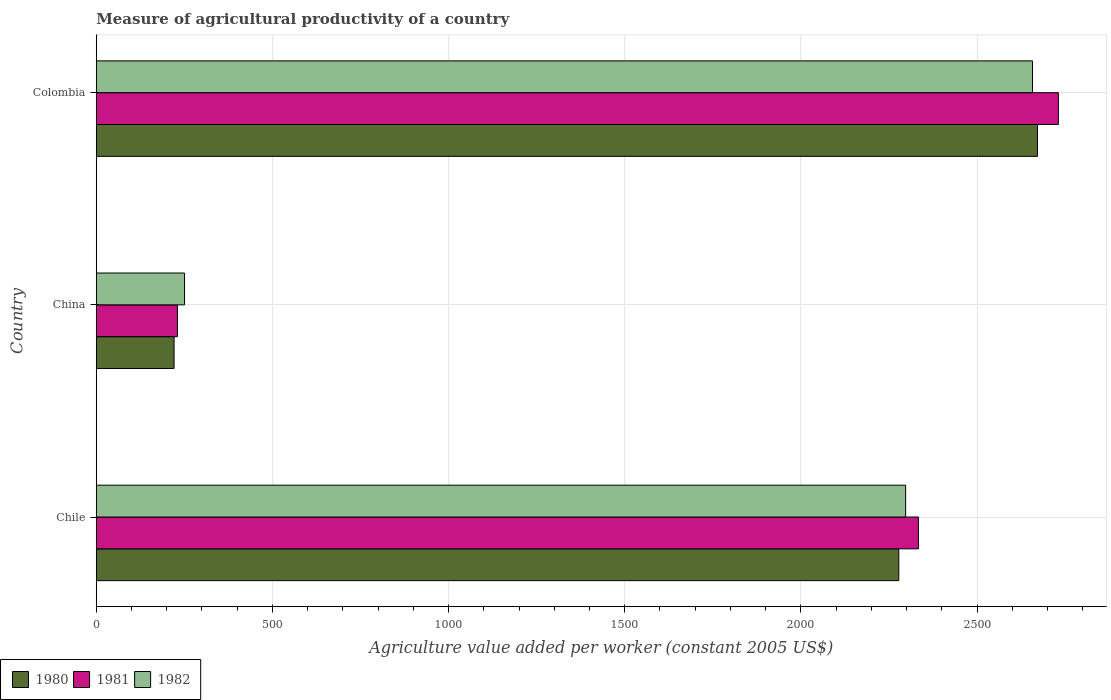How many different coloured bars are there?
Your answer should be very brief. 3. In how many cases, is the number of bars for a given country not equal to the number of legend labels?
Provide a succinct answer. 0. What is the measure of agricultural productivity in 1980 in Colombia?
Your answer should be compact. 2671.6. Across all countries, what is the maximum measure of agricultural productivity in 1981?
Keep it short and to the point. 2731.02. Across all countries, what is the minimum measure of agricultural productivity in 1980?
Offer a terse response. 220.85. In which country was the measure of agricultural productivity in 1982 minimum?
Your answer should be compact. China. What is the total measure of agricultural productivity in 1981 in the graph?
Offer a terse response. 5295.08. What is the difference between the measure of agricultural productivity in 1981 in Chile and that in China?
Provide a short and direct response. 2103.3. What is the difference between the measure of agricultural productivity in 1981 in China and the measure of agricultural productivity in 1982 in Chile?
Your answer should be very brief. -2067.07. What is the average measure of agricultural productivity in 1982 per country?
Ensure brevity in your answer.  1735.19. What is the difference between the measure of agricultural productivity in 1982 and measure of agricultural productivity in 1981 in Colombia?
Offer a terse response. -73.46. In how many countries, is the measure of agricultural productivity in 1980 greater than 2000 US$?
Ensure brevity in your answer.  2. What is the ratio of the measure of agricultural productivity in 1982 in China to that in Colombia?
Ensure brevity in your answer.  0.09. Is the measure of agricultural productivity in 1981 in Chile less than that in China?
Your response must be concise. No. Is the difference between the measure of agricultural productivity in 1982 in Chile and China greater than the difference between the measure of agricultural productivity in 1981 in Chile and China?
Your answer should be compact. No. What is the difference between the highest and the second highest measure of agricultural productivity in 1981?
Offer a terse response. 397.34. What is the difference between the highest and the lowest measure of agricultural productivity in 1980?
Offer a terse response. 2450.74. What is the difference between two consecutive major ticks on the X-axis?
Provide a succinct answer. 500. Are the values on the major ticks of X-axis written in scientific E-notation?
Provide a short and direct response. No. Does the graph contain any zero values?
Offer a very short reply. No. Does the graph contain grids?
Make the answer very short. Yes. How many legend labels are there?
Ensure brevity in your answer.  3. How are the legend labels stacked?
Provide a short and direct response. Horizontal. What is the title of the graph?
Offer a terse response. Measure of agricultural productivity of a country. Does "1977" appear as one of the legend labels in the graph?
Offer a very short reply. No. What is the label or title of the X-axis?
Your answer should be very brief. Agriculture value added per worker (constant 2005 US$). What is the Agriculture value added per worker (constant 2005 US$) in 1980 in Chile?
Your answer should be very brief. 2277.98. What is the Agriculture value added per worker (constant 2005 US$) in 1981 in Chile?
Offer a very short reply. 2333.68. What is the Agriculture value added per worker (constant 2005 US$) in 1982 in Chile?
Your answer should be compact. 2297.45. What is the Agriculture value added per worker (constant 2005 US$) of 1980 in China?
Make the answer very short. 220.85. What is the Agriculture value added per worker (constant 2005 US$) in 1981 in China?
Your answer should be compact. 230.38. What is the Agriculture value added per worker (constant 2005 US$) of 1982 in China?
Your answer should be compact. 250.55. What is the Agriculture value added per worker (constant 2005 US$) of 1980 in Colombia?
Give a very brief answer. 2671.6. What is the Agriculture value added per worker (constant 2005 US$) in 1981 in Colombia?
Make the answer very short. 2731.02. What is the Agriculture value added per worker (constant 2005 US$) in 1982 in Colombia?
Your answer should be compact. 2657.56. Across all countries, what is the maximum Agriculture value added per worker (constant 2005 US$) of 1980?
Your response must be concise. 2671.6. Across all countries, what is the maximum Agriculture value added per worker (constant 2005 US$) in 1981?
Your answer should be compact. 2731.02. Across all countries, what is the maximum Agriculture value added per worker (constant 2005 US$) of 1982?
Make the answer very short. 2657.56. Across all countries, what is the minimum Agriculture value added per worker (constant 2005 US$) of 1980?
Your answer should be very brief. 220.85. Across all countries, what is the minimum Agriculture value added per worker (constant 2005 US$) of 1981?
Offer a terse response. 230.38. Across all countries, what is the minimum Agriculture value added per worker (constant 2005 US$) in 1982?
Your answer should be very brief. 250.55. What is the total Agriculture value added per worker (constant 2005 US$) in 1980 in the graph?
Your answer should be very brief. 5170.43. What is the total Agriculture value added per worker (constant 2005 US$) in 1981 in the graph?
Your response must be concise. 5295.08. What is the total Agriculture value added per worker (constant 2005 US$) of 1982 in the graph?
Offer a very short reply. 5205.57. What is the difference between the Agriculture value added per worker (constant 2005 US$) of 1980 in Chile and that in China?
Your answer should be compact. 2057.13. What is the difference between the Agriculture value added per worker (constant 2005 US$) in 1981 in Chile and that in China?
Your answer should be compact. 2103.3. What is the difference between the Agriculture value added per worker (constant 2005 US$) in 1982 in Chile and that in China?
Make the answer very short. 2046.9. What is the difference between the Agriculture value added per worker (constant 2005 US$) in 1980 in Chile and that in Colombia?
Provide a short and direct response. -393.61. What is the difference between the Agriculture value added per worker (constant 2005 US$) of 1981 in Chile and that in Colombia?
Your response must be concise. -397.34. What is the difference between the Agriculture value added per worker (constant 2005 US$) in 1982 in Chile and that in Colombia?
Keep it short and to the point. -360.11. What is the difference between the Agriculture value added per worker (constant 2005 US$) of 1980 in China and that in Colombia?
Ensure brevity in your answer.  -2450.74. What is the difference between the Agriculture value added per worker (constant 2005 US$) in 1981 in China and that in Colombia?
Make the answer very short. -2500.64. What is the difference between the Agriculture value added per worker (constant 2005 US$) in 1982 in China and that in Colombia?
Keep it short and to the point. -2407.01. What is the difference between the Agriculture value added per worker (constant 2005 US$) in 1980 in Chile and the Agriculture value added per worker (constant 2005 US$) in 1981 in China?
Offer a very short reply. 2047.6. What is the difference between the Agriculture value added per worker (constant 2005 US$) in 1980 in Chile and the Agriculture value added per worker (constant 2005 US$) in 1982 in China?
Offer a very short reply. 2027.43. What is the difference between the Agriculture value added per worker (constant 2005 US$) of 1981 in Chile and the Agriculture value added per worker (constant 2005 US$) of 1982 in China?
Offer a terse response. 2083.13. What is the difference between the Agriculture value added per worker (constant 2005 US$) in 1980 in Chile and the Agriculture value added per worker (constant 2005 US$) in 1981 in Colombia?
Offer a terse response. -453.04. What is the difference between the Agriculture value added per worker (constant 2005 US$) of 1980 in Chile and the Agriculture value added per worker (constant 2005 US$) of 1982 in Colombia?
Offer a very short reply. -379.58. What is the difference between the Agriculture value added per worker (constant 2005 US$) of 1981 in Chile and the Agriculture value added per worker (constant 2005 US$) of 1982 in Colombia?
Your answer should be very brief. -323.88. What is the difference between the Agriculture value added per worker (constant 2005 US$) in 1980 in China and the Agriculture value added per worker (constant 2005 US$) in 1981 in Colombia?
Offer a terse response. -2510.17. What is the difference between the Agriculture value added per worker (constant 2005 US$) in 1980 in China and the Agriculture value added per worker (constant 2005 US$) in 1982 in Colombia?
Provide a short and direct response. -2436.71. What is the difference between the Agriculture value added per worker (constant 2005 US$) in 1981 in China and the Agriculture value added per worker (constant 2005 US$) in 1982 in Colombia?
Offer a very short reply. -2427.18. What is the average Agriculture value added per worker (constant 2005 US$) in 1980 per country?
Ensure brevity in your answer.  1723.48. What is the average Agriculture value added per worker (constant 2005 US$) in 1981 per country?
Give a very brief answer. 1765.03. What is the average Agriculture value added per worker (constant 2005 US$) of 1982 per country?
Your response must be concise. 1735.19. What is the difference between the Agriculture value added per worker (constant 2005 US$) in 1980 and Agriculture value added per worker (constant 2005 US$) in 1981 in Chile?
Your answer should be compact. -55.7. What is the difference between the Agriculture value added per worker (constant 2005 US$) of 1980 and Agriculture value added per worker (constant 2005 US$) of 1982 in Chile?
Provide a short and direct response. -19.47. What is the difference between the Agriculture value added per worker (constant 2005 US$) of 1981 and Agriculture value added per worker (constant 2005 US$) of 1982 in Chile?
Offer a terse response. 36.23. What is the difference between the Agriculture value added per worker (constant 2005 US$) in 1980 and Agriculture value added per worker (constant 2005 US$) in 1981 in China?
Ensure brevity in your answer.  -9.53. What is the difference between the Agriculture value added per worker (constant 2005 US$) of 1980 and Agriculture value added per worker (constant 2005 US$) of 1982 in China?
Offer a terse response. -29.7. What is the difference between the Agriculture value added per worker (constant 2005 US$) of 1981 and Agriculture value added per worker (constant 2005 US$) of 1982 in China?
Offer a terse response. -20.17. What is the difference between the Agriculture value added per worker (constant 2005 US$) in 1980 and Agriculture value added per worker (constant 2005 US$) in 1981 in Colombia?
Your answer should be compact. -59.42. What is the difference between the Agriculture value added per worker (constant 2005 US$) in 1980 and Agriculture value added per worker (constant 2005 US$) in 1982 in Colombia?
Provide a succinct answer. 14.03. What is the difference between the Agriculture value added per worker (constant 2005 US$) in 1981 and Agriculture value added per worker (constant 2005 US$) in 1982 in Colombia?
Offer a very short reply. 73.46. What is the ratio of the Agriculture value added per worker (constant 2005 US$) of 1980 in Chile to that in China?
Offer a terse response. 10.31. What is the ratio of the Agriculture value added per worker (constant 2005 US$) in 1981 in Chile to that in China?
Offer a very short reply. 10.13. What is the ratio of the Agriculture value added per worker (constant 2005 US$) in 1982 in Chile to that in China?
Your response must be concise. 9.17. What is the ratio of the Agriculture value added per worker (constant 2005 US$) of 1980 in Chile to that in Colombia?
Ensure brevity in your answer.  0.85. What is the ratio of the Agriculture value added per worker (constant 2005 US$) of 1981 in Chile to that in Colombia?
Provide a succinct answer. 0.85. What is the ratio of the Agriculture value added per worker (constant 2005 US$) of 1982 in Chile to that in Colombia?
Keep it short and to the point. 0.86. What is the ratio of the Agriculture value added per worker (constant 2005 US$) in 1980 in China to that in Colombia?
Give a very brief answer. 0.08. What is the ratio of the Agriculture value added per worker (constant 2005 US$) of 1981 in China to that in Colombia?
Your answer should be compact. 0.08. What is the ratio of the Agriculture value added per worker (constant 2005 US$) of 1982 in China to that in Colombia?
Offer a terse response. 0.09. What is the difference between the highest and the second highest Agriculture value added per worker (constant 2005 US$) in 1980?
Provide a short and direct response. 393.61. What is the difference between the highest and the second highest Agriculture value added per worker (constant 2005 US$) of 1981?
Offer a very short reply. 397.34. What is the difference between the highest and the second highest Agriculture value added per worker (constant 2005 US$) in 1982?
Make the answer very short. 360.11. What is the difference between the highest and the lowest Agriculture value added per worker (constant 2005 US$) in 1980?
Make the answer very short. 2450.74. What is the difference between the highest and the lowest Agriculture value added per worker (constant 2005 US$) in 1981?
Give a very brief answer. 2500.64. What is the difference between the highest and the lowest Agriculture value added per worker (constant 2005 US$) in 1982?
Make the answer very short. 2407.01. 